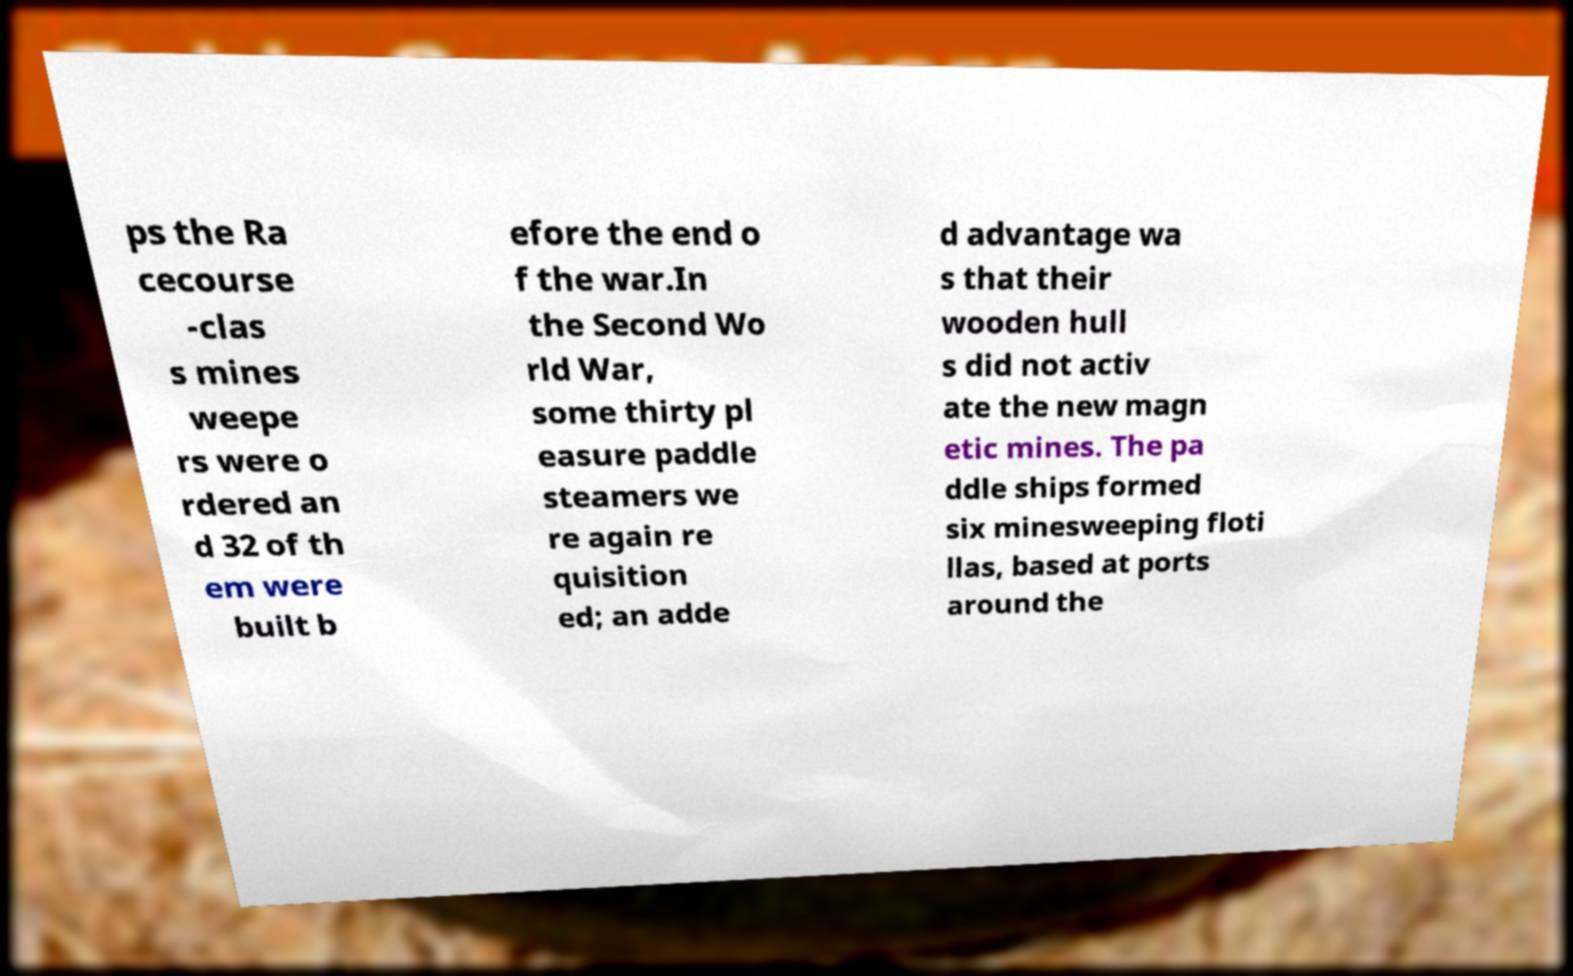I need the written content from this picture converted into text. Can you do that? ps the Ra cecourse -clas s mines weepe rs were o rdered an d 32 of th em were built b efore the end o f the war.In the Second Wo rld War, some thirty pl easure paddle steamers we re again re quisition ed; an adde d advantage wa s that their wooden hull s did not activ ate the new magn etic mines. The pa ddle ships formed six minesweeping floti llas, based at ports around the 